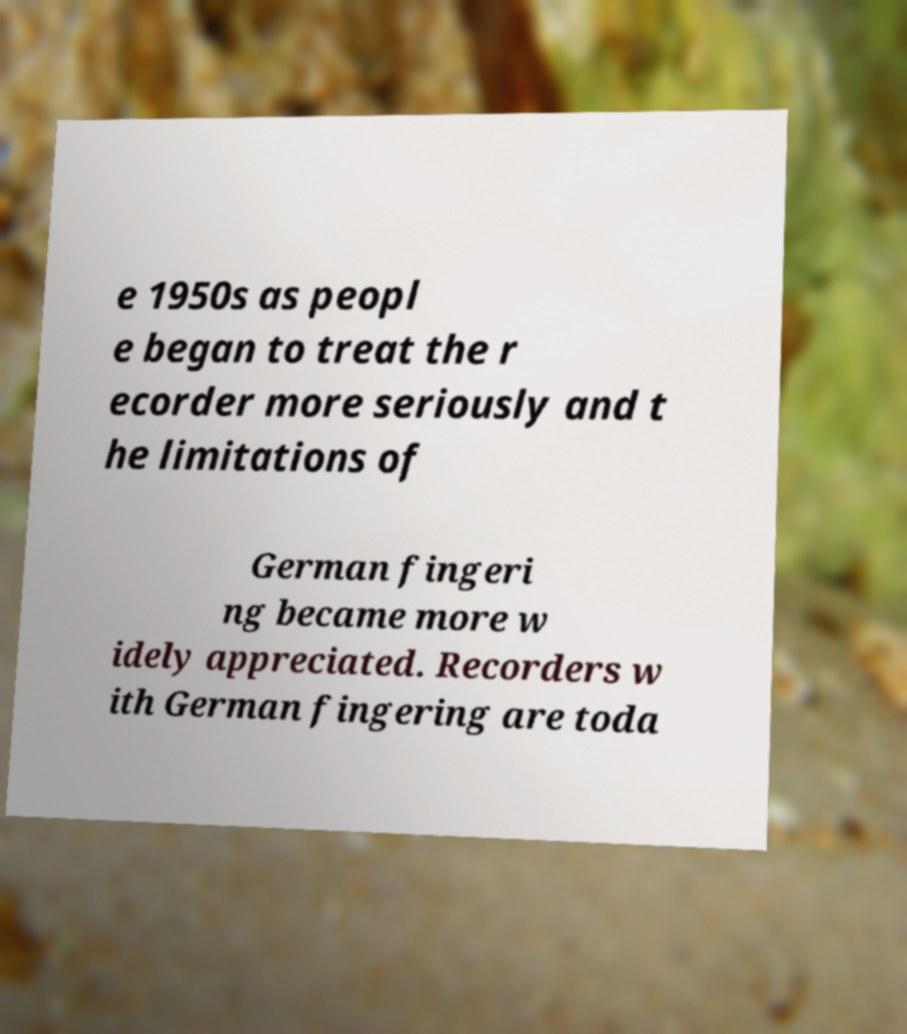Can you read and provide the text displayed in the image?This photo seems to have some interesting text. Can you extract and type it out for me? e 1950s as peopl e began to treat the r ecorder more seriously and t he limitations of German fingeri ng became more w idely appreciated. Recorders w ith German fingering are toda 